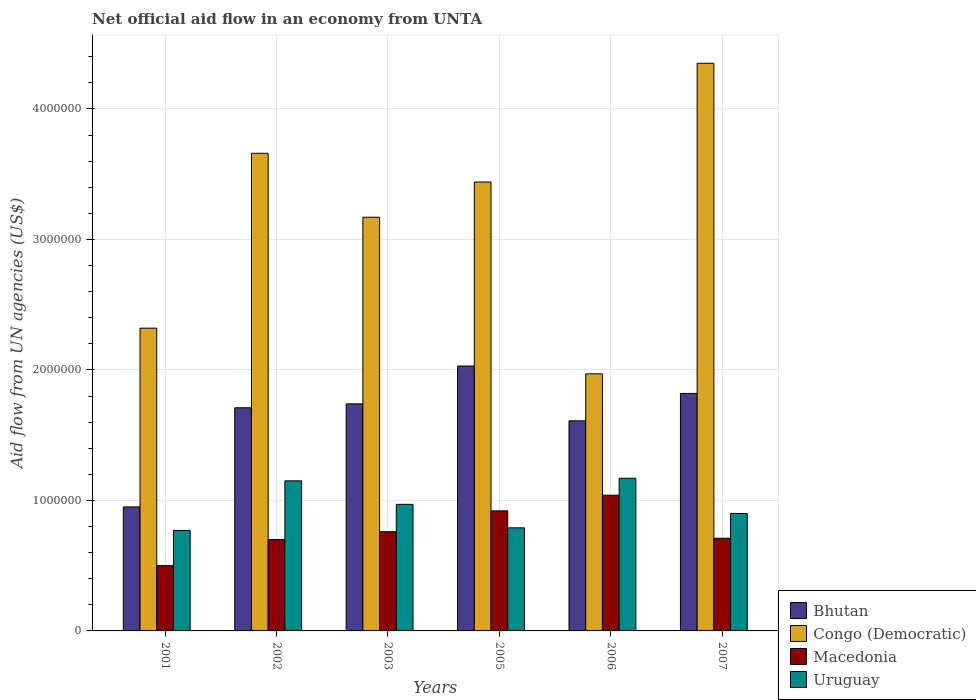How many groups of bars are there?
Provide a succinct answer. 6. Are the number of bars on each tick of the X-axis equal?
Ensure brevity in your answer.  Yes. How many bars are there on the 2nd tick from the left?
Ensure brevity in your answer.  4. How many bars are there on the 6th tick from the right?
Provide a short and direct response. 4. What is the label of the 4th group of bars from the left?
Keep it short and to the point. 2005. What is the net official aid flow in Macedonia in 2006?
Your answer should be compact. 1.04e+06. Across all years, what is the maximum net official aid flow in Congo (Democratic)?
Provide a short and direct response. 4.35e+06. In which year was the net official aid flow in Bhutan maximum?
Offer a very short reply. 2005. What is the total net official aid flow in Macedonia in the graph?
Offer a terse response. 4.63e+06. What is the difference between the net official aid flow in Bhutan in 2002 and that in 2006?
Keep it short and to the point. 1.00e+05. What is the difference between the net official aid flow in Macedonia in 2003 and the net official aid flow in Bhutan in 2006?
Keep it short and to the point. -8.50e+05. What is the average net official aid flow in Macedonia per year?
Your answer should be compact. 7.72e+05. In the year 2006, what is the difference between the net official aid flow in Bhutan and net official aid flow in Macedonia?
Keep it short and to the point. 5.70e+05. In how many years, is the net official aid flow in Uruguay greater than 2600000 US$?
Your answer should be compact. 0. Is the difference between the net official aid flow in Bhutan in 2001 and 2005 greater than the difference between the net official aid flow in Macedonia in 2001 and 2005?
Your response must be concise. No. Is the sum of the net official aid flow in Bhutan in 2002 and 2007 greater than the maximum net official aid flow in Congo (Democratic) across all years?
Your answer should be compact. No. What does the 3rd bar from the left in 2002 represents?
Your answer should be compact. Macedonia. What does the 2nd bar from the right in 2003 represents?
Your answer should be very brief. Macedonia. Are all the bars in the graph horizontal?
Keep it short and to the point. No. Are the values on the major ticks of Y-axis written in scientific E-notation?
Offer a terse response. No. What is the title of the graph?
Ensure brevity in your answer.  Net official aid flow in an economy from UNTA. Does "Equatorial Guinea" appear as one of the legend labels in the graph?
Ensure brevity in your answer.  No. What is the label or title of the Y-axis?
Offer a very short reply. Aid flow from UN agencies (US$). What is the Aid flow from UN agencies (US$) of Bhutan in 2001?
Offer a terse response. 9.50e+05. What is the Aid flow from UN agencies (US$) of Congo (Democratic) in 2001?
Provide a succinct answer. 2.32e+06. What is the Aid flow from UN agencies (US$) of Uruguay in 2001?
Give a very brief answer. 7.70e+05. What is the Aid flow from UN agencies (US$) of Bhutan in 2002?
Ensure brevity in your answer.  1.71e+06. What is the Aid flow from UN agencies (US$) of Congo (Democratic) in 2002?
Provide a short and direct response. 3.66e+06. What is the Aid flow from UN agencies (US$) in Uruguay in 2002?
Your answer should be very brief. 1.15e+06. What is the Aid flow from UN agencies (US$) of Bhutan in 2003?
Provide a succinct answer. 1.74e+06. What is the Aid flow from UN agencies (US$) in Congo (Democratic) in 2003?
Keep it short and to the point. 3.17e+06. What is the Aid flow from UN agencies (US$) of Macedonia in 2003?
Offer a terse response. 7.60e+05. What is the Aid flow from UN agencies (US$) of Uruguay in 2003?
Offer a terse response. 9.70e+05. What is the Aid flow from UN agencies (US$) in Bhutan in 2005?
Your response must be concise. 2.03e+06. What is the Aid flow from UN agencies (US$) in Congo (Democratic) in 2005?
Provide a short and direct response. 3.44e+06. What is the Aid flow from UN agencies (US$) of Macedonia in 2005?
Your response must be concise. 9.20e+05. What is the Aid flow from UN agencies (US$) of Uruguay in 2005?
Ensure brevity in your answer.  7.90e+05. What is the Aid flow from UN agencies (US$) of Bhutan in 2006?
Give a very brief answer. 1.61e+06. What is the Aid flow from UN agencies (US$) of Congo (Democratic) in 2006?
Offer a very short reply. 1.97e+06. What is the Aid flow from UN agencies (US$) of Macedonia in 2006?
Give a very brief answer. 1.04e+06. What is the Aid flow from UN agencies (US$) of Uruguay in 2006?
Offer a terse response. 1.17e+06. What is the Aid flow from UN agencies (US$) in Bhutan in 2007?
Provide a short and direct response. 1.82e+06. What is the Aid flow from UN agencies (US$) in Congo (Democratic) in 2007?
Provide a succinct answer. 4.35e+06. What is the Aid flow from UN agencies (US$) of Macedonia in 2007?
Your response must be concise. 7.10e+05. Across all years, what is the maximum Aid flow from UN agencies (US$) of Bhutan?
Give a very brief answer. 2.03e+06. Across all years, what is the maximum Aid flow from UN agencies (US$) of Congo (Democratic)?
Provide a succinct answer. 4.35e+06. Across all years, what is the maximum Aid flow from UN agencies (US$) of Macedonia?
Keep it short and to the point. 1.04e+06. Across all years, what is the maximum Aid flow from UN agencies (US$) in Uruguay?
Ensure brevity in your answer.  1.17e+06. Across all years, what is the minimum Aid flow from UN agencies (US$) of Bhutan?
Your response must be concise. 9.50e+05. Across all years, what is the minimum Aid flow from UN agencies (US$) of Congo (Democratic)?
Your answer should be very brief. 1.97e+06. Across all years, what is the minimum Aid flow from UN agencies (US$) in Macedonia?
Provide a succinct answer. 5.00e+05. Across all years, what is the minimum Aid flow from UN agencies (US$) of Uruguay?
Your response must be concise. 7.70e+05. What is the total Aid flow from UN agencies (US$) in Bhutan in the graph?
Offer a terse response. 9.86e+06. What is the total Aid flow from UN agencies (US$) of Congo (Democratic) in the graph?
Your answer should be very brief. 1.89e+07. What is the total Aid flow from UN agencies (US$) in Macedonia in the graph?
Provide a succinct answer. 4.63e+06. What is the total Aid flow from UN agencies (US$) of Uruguay in the graph?
Give a very brief answer. 5.75e+06. What is the difference between the Aid flow from UN agencies (US$) of Bhutan in 2001 and that in 2002?
Your answer should be very brief. -7.60e+05. What is the difference between the Aid flow from UN agencies (US$) in Congo (Democratic) in 2001 and that in 2002?
Make the answer very short. -1.34e+06. What is the difference between the Aid flow from UN agencies (US$) of Uruguay in 2001 and that in 2002?
Provide a succinct answer. -3.80e+05. What is the difference between the Aid flow from UN agencies (US$) of Bhutan in 2001 and that in 2003?
Give a very brief answer. -7.90e+05. What is the difference between the Aid flow from UN agencies (US$) of Congo (Democratic) in 2001 and that in 2003?
Give a very brief answer. -8.50e+05. What is the difference between the Aid flow from UN agencies (US$) of Uruguay in 2001 and that in 2003?
Make the answer very short. -2.00e+05. What is the difference between the Aid flow from UN agencies (US$) in Bhutan in 2001 and that in 2005?
Give a very brief answer. -1.08e+06. What is the difference between the Aid flow from UN agencies (US$) of Congo (Democratic) in 2001 and that in 2005?
Offer a very short reply. -1.12e+06. What is the difference between the Aid flow from UN agencies (US$) of Macedonia in 2001 and that in 2005?
Your answer should be very brief. -4.20e+05. What is the difference between the Aid flow from UN agencies (US$) in Uruguay in 2001 and that in 2005?
Your answer should be compact. -2.00e+04. What is the difference between the Aid flow from UN agencies (US$) in Bhutan in 2001 and that in 2006?
Provide a short and direct response. -6.60e+05. What is the difference between the Aid flow from UN agencies (US$) of Congo (Democratic) in 2001 and that in 2006?
Your response must be concise. 3.50e+05. What is the difference between the Aid flow from UN agencies (US$) of Macedonia in 2001 and that in 2006?
Make the answer very short. -5.40e+05. What is the difference between the Aid flow from UN agencies (US$) of Uruguay in 2001 and that in 2006?
Your response must be concise. -4.00e+05. What is the difference between the Aid flow from UN agencies (US$) of Bhutan in 2001 and that in 2007?
Offer a terse response. -8.70e+05. What is the difference between the Aid flow from UN agencies (US$) of Congo (Democratic) in 2001 and that in 2007?
Offer a terse response. -2.03e+06. What is the difference between the Aid flow from UN agencies (US$) in Congo (Democratic) in 2002 and that in 2003?
Your response must be concise. 4.90e+05. What is the difference between the Aid flow from UN agencies (US$) of Macedonia in 2002 and that in 2003?
Provide a short and direct response. -6.00e+04. What is the difference between the Aid flow from UN agencies (US$) of Uruguay in 2002 and that in 2003?
Your response must be concise. 1.80e+05. What is the difference between the Aid flow from UN agencies (US$) of Bhutan in 2002 and that in 2005?
Ensure brevity in your answer.  -3.20e+05. What is the difference between the Aid flow from UN agencies (US$) in Congo (Democratic) in 2002 and that in 2005?
Offer a terse response. 2.20e+05. What is the difference between the Aid flow from UN agencies (US$) of Uruguay in 2002 and that in 2005?
Ensure brevity in your answer.  3.60e+05. What is the difference between the Aid flow from UN agencies (US$) of Bhutan in 2002 and that in 2006?
Your answer should be very brief. 1.00e+05. What is the difference between the Aid flow from UN agencies (US$) in Congo (Democratic) in 2002 and that in 2006?
Offer a terse response. 1.69e+06. What is the difference between the Aid flow from UN agencies (US$) of Macedonia in 2002 and that in 2006?
Keep it short and to the point. -3.40e+05. What is the difference between the Aid flow from UN agencies (US$) of Uruguay in 2002 and that in 2006?
Offer a terse response. -2.00e+04. What is the difference between the Aid flow from UN agencies (US$) in Bhutan in 2002 and that in 2007?
Make the answer very short. -1.10e+05. What is the difference between the Aid flow from UN agencies (US$) of Congo (Democratic) in 2002 and that in 2007?
Provide a succinct answer. -6.90e+05. What is the difference between the Aid flow from UN agencies (US$) in Uruguay in 2002 and that in 2007?
Provide a succinct answer. 2.50e+05. What is the difference between the Aid flow from UN agencies (US$) in Bhutan in 2003 and that in 2005?
Offer a terse response. -2.90e+05. What is the difference between the Aid flow from UN agencies (US$) in Congo (Democratic) in 2003 and that in 2005?
Provide a succinct answer. -2.70e+05. What is the difference between the Aid flow from UN agencies (US$) in Macedonia in 2003 and that in 2005?
Your answer should be compact. -1.60e+05. What is the difference between the Aid flow from UN agencies (US$) of Uruguay in 2003 and that in 2005?
Keep it short and to the point. 1.80e+05. What is the difference between the Aid flow from UN agencies (US$) of Bhutan in 2003 and that in 2006?
Give a very brief answer. 1.30e+05. What is the difference between the Aid flow from UN agencies (US$) in Congo (Democratic) in 2003 and that in 2006?
Provide a short and direct response. 1.20e+06. What is the difference between the Aid flow from UN agencies (US$) of Macedonia in 2003 and that in 2006?
Your answer should be very brief. -2.80e+05. What is the difference between the Aid flow from UN agencies (US$) of Uruguay in 2003 and that in 2006?
Your answer should be very brief. -2.00e+05. What is the difference between the Aid flow from UN agencies (US$) of Congo (Democratic) in 2003 and that in 2007?
Provide a succinct answer. -1.18e+06. What is the difference between the Aid flow from UN agencies (US$) of Macedonia in 2003 and that in 2007?
Ensure brevity in your answer.  5.00e+04. What is the difference between the Aid flow from UN agencies (US$) of Bhutan in 2005 and that in 2006?
Your answer should be compact. 4.20e+05. What is the difference between the Aid flow from UN agencies (US$) of Congo (Democratic) in 2005 and that in 2006?
Offer a very short reply. 1.47e+06. What is the difference between the Aid flow from UN agencies (US$) in Macedonia in 2005 and that in 2006?
Ensure brevity in your answer.  -1.20e+05. What is the difference between the Aid flow from UN agencies (US$) of Uruguay in 2005 and that in 2006?
Offer a very short reply. -3.80e+05. What is the difference between the Aid flow from UN agencies (US$) in Bhutan in 2005 and that in 2007?
Ensure brevity in your answer.  2.10e+05. What is the difference between the Aid flow from UN agencies (US$) in Congo (Democratic) in 2005 and that in 2007?
Ensure brevity in your answer.  -9.10e+05. What is the difference between the Aid flow from UN agencies (US$) of Bhutan in 2006 and that in 2007?
Ensure brevity in your answer.  -2.10e+05. What is the difference between the Aid flow from UN agencies (US$) of Congo (Democratic) in 2006 and that in 2007?
Your response must be concise. -2.38e+06. What is the difference between the Aid flow from UN agencies (US$) in Macedonia in 2006 and that in 2007?
Offer a terse response. 3.30e+05. What is the difference between the Aid flow from UN agencies (US$) in Uruguay in 2006 and that in 2007?
Make the answer very short. 2.70e+05. What is the difference between the Aid flow from UN agencies (US$) in Bhutan in 2001 and the Aid flow from UN agencies (US$) in Congo (Democratic) in 2002?
Provide a succinct answer. -2.71e+06. What is the difference between the Aid flow from UN agencies (US$) in Bhutan in 2001 and the Aid flow from UN agencies (US$) in Uruguay in 2002?
Your answer should be very brief. -2.00e+05. What is the difference between the Aid flow from UN agencies (US$) of Congo (Democratic) in 2001 and the Aid flow from UN agencies (US$) of Macedonia in 2002?
Ensure brevity in your answer.  1.62e+06. What is the difference between the Aid flow from UN agencies (US$) of Congo (Democratic) in 2001 and the Aid flow from UN agencies (US$) of Uruguay in 2002?
Your answer should be compact. 1.17e+06. What is the difference between the Aid flow from UN agencies (US$) in Macedonia in 2001 and the Aid flow from UN agencies (US$) in Uruguay in 2002?
Ensure brevity in your answer.  -6.50e+05. What is the difference between the Aid flow from UN agencies (US$) in Bhutan in 2001 and the Aid flow from UN agencies (US$) in Congo (Democratic) in 2003?
Provide a succinct answer. -2.22e+06. What is the difference between the Aid flow from UN agencies (US$) of Bhutan in 2001 and the Aid flow from UN agencies (US$) of Uruguay in 2003?
Provide a short and direct response. -2.00e+04. What is the difference between the Aid flow from UN agencies (US$) of Congo (Democratic) in 2001 and the Aid flow from UN agencies (US$) of Macedonia in 2003?
Provide a succinct answer. 1.56e+06. What is the difference between the Aid flow from UN agencies (US$) of Congo (Democratic) in 2001 and the Aid flow from UN agencies (US$) of Uruguay in 2003?
Make the answer very short. 1.35e+06. What is the difference between the Aid flow from UN agencies (US$) of Macedonia in 2001 and the Aid flow from UN agencies (US$) of Uruguay in 2003?
Give a very brief answer. -4.70e+05. What is the difference between the Aid flow from UN agencies (US$) of Bhutan in 2001 and the Aid flow from UN agencies (US$) of Congo (Democratic) in 2005?
Your response must be concise. -2.49e+06. What is the difference between the Aid flow from UN agencies (US$) of Bhutan in 2001 and the Aid flow from UN agencies (US$) of Macedonia in 2005?
Give a very brief answer. 3.00e+04. What is the difference between the Aid flow from UN agencies (US$) of Bhutan in 2001 and the Aid flow from UN agencies (US$) of Uruguay in 2005?
Give a very brief answer. 1.60e+05. What is the difference between the Aid flow from UN agencies (US$) in Congo (Democratic) in 2001 and the Aid flow from UN agencies (US$) in Macedonia in 2005?
Your response must be concise. 1.40e+06. What is the difference between the Aid flow from UN agencies (US$) in Congo (Democratic) in 2001 and the Aid flow from UN agencies (US$) in Uruguay in 2005?
Ensure brevity in your answer.  1.53e+06. What is the difference between the Aid flow from UN agencies (US$) in Bhutan in 2001 and the Aid flow from UN agencies (US$) in Congo (Democratic) in 2006?
Your answer should be compact. -1.02e+06. What is the difference between the Aid flow from UN agencies (US$) of Congo (Democratic) in 2001 and the Aid flow from UN agencies (US$) of Macedonia in 2006?
Your answer should be very brief. 1.28e+06. What is the difference between the Aid flow from UN agencies (US$) of Congo (Democratic) in 2001 and the Aid flow from UN agencies (US$) of Uruguay in 2006?
Offer a terse response. 1.15e+06. What is the difference between the Aid flow from UN agencies (US$) in Macedonia in 2001 and the Aid flow from UN agencies (US$) in Uruguay in 2006?
Your answer should be very brief. -6.70e+05. What is the difference between the Aid flow from UN agencies (US$) in Bhutan in 2001 and the Aid flow from UN agencies (US$) in Congo (Democratic) in 2007?
Provide a short and direct response. -3.40e+06. What is the difference between the Aid flow from UN agencies (US$) in Bhutan in 2001 and the Aid flow from UN agencies (US$) in Uruguay in 2007?
Provide a succinct answer. 5.00e+04. What is the difference between the Aid flow from UN agencies (US$) in Congo (Democratic) in 2001 and the Aid flow from UN agencies (US$) in Macedonia in 2007?
Your response must be concise. 1.61e+06. What is the difference between the Aid flow from UN agencies (US$) in Congo (Democratic) in 2001 and the Aid flow from UN agencies (US$) in Uruguay in 2007?
Keep it short and to the point. 1.42e+06. What is the difference between the Aid flow from UN agencies (US$) in Macedonia in 2001 and the Aid flow from UN agencies (US$) in Uruguay in 2007?
Your response must be concise. -4.00e+05. What is the difference between the Aid flow from UN agencies (US$) of Bhutan in 2002 and the Aid flow from UN agencies (US$) of Congo (Democratic) in 2003?
Offer a very short reply. -1.46e+06. What is the difference between the Aid flow from UN agencies (US$) in Bhutan in 2002 and the Aid flow from UN agencies (US$) in Macedonia in 2003?
Your answer should be very brief. 9.50e+05. What is the difference between the Aid flow from UN agencies (US$) in Bhutan in 2002 and the Aid flow from UN agencies (US$) in Uruguay in 2003?
Your answer should be compact. 7.40e+05. What is the difference between the Aid flow from UN agencies (US$) of Congo (Democratic) in 2002 and the Aid flow from UN agencies (US$) of Macedonia in 2003?
Give a very brief answer. 2.90e+06. What is the difference between the Aid flow from UN agencies (US$) in Congo (Democratic) in 2002 and the Aid flow from UN agencies (US$) in Uruguay in 2003?
Your answer should be very brief. 2.69e+06. What is the difference between the Aid flow from UN agencies (US$) of Bhutan in 2002 and the Aid flow from UN agencies (US$) of Congo (Democratic) in 2005?
Make the answer very short. -1.73e+06. What is the difference between the Aid flow from UN agencies (US$) of Bhutan in 2002 and the Aid flow from UN agencies (US$) of Macedonia in 2005?
Keep it short and to the point. 7.90e+05. What is the difference between the Aid flow from UN agencies (US$) of Bhutan in 2002 and the Aid flow from UN agencies (US$) of Uruguay in 2005?
Your answer should be compact. 9.20e+05. What is the difference between the Aid flow from UN agencies (US$) in Congo (Democratic) in 2002 and the Aid flow from UN agencies (US$) in Macedonia in 2005?
Provide a succinct answer. 2.74e+06. What is the difference between the Aid flow from UN agencies (US$) in Congo (Democratic) in 2002 and the Aid flow from UN agencies (US$) in Uruguay in 2005?
Keep it short and to the point. 2.87e+06. What is the difference between the Aid flow from UN agencies (US$) in Macedonia in 2002 and the Aid flow from UN agencies (US$) in Uruguay in 2005?
Offer a very short reply. -9.00e+04. What is the difference between the Aid flow from UN agencies (US$) of Bhutan in 2002 and the Aid flow from UN agencies (US$) of Macedonia in 2006?
Your answer should be very brief. 6.70e+05. What is the difference between the Aid flow from UN agencies (US$) of Bhutan in 2002 and the Aid flow from UN agencies (US$) of Uruguay in 2006?
Your answer should be compact. 5.40e+05. What is the difference between the Aid flow from UN agencies (US$) in Congo (Democratic) in 2002 and the Aid flow from UN agencies (US$) in Macedonia in 2006?
Keep it short and to the point. 2.62e+06. What is the difference between the Aid flow from UN agencies (US$) in Congo (Democratic) in 2002 and the Aid flow from UN agencies (US$) in Uruguay in 2006?
Give a very brief answer. 2.49e+06. What is the difference between the Aid flow from UN agencies (US$) of Macedonia in 2002 and the Aid flow from UN agencies (US$) of Uruguay in 2006?
Your answer should be compact. -4.70e+05. What is the difference between the Aid flow from UN agencies (US$) of Bhutan in 2002 and the Aid flow from UN agencies (US$) of Congo (Democratic) in 2007?
Your answer should be very brief. -2.64e+06. What is the difference between the Aid flow from UN agencies (US$) in Bhutan in 2002 and the Aid flow from UN agencies (US$) in Uruguay in 2007?
Make the answer very short. 8.10e+05. What is the difference between the Aid flow from UN agencies (US$) in Congo (Democratic) in 2002 and the Aid flow from UN agencies (US$) in Macedonia in 2007?
Your answer should be very brief. 2.95e+06. What is the difference between the Aid flow from UN agencies (US$) of Congo (Democratic) in 2002 and the Aid flow from UN agencies (US$) of Uruguay in 2007?
Give a very brief answer. 2.76e+06. What is the difference between the Aid flow from UN agencies (US$) of Bhutan in 2003 and the Aid flow from UN agencies (US$) of Congo (Democratic) in 2005?
Offer a very short reply. -1.70e+06. What is the difference between the Aid flow from UN agencies (US$) in Bhutan in 2003 and the Aid flow from UN agencies (US$) in Macedonia in 2005?
Your answer should be very brief. 8.20e+05. What is the difference between the Aid flow from UN agencies (US$) in Bhutan in 2003 and the Aid flow from UN agencies (US$) in Uruguay in 2005?
Make the answer very short. 9.50e+05. What is the difference between the Aid flow from UN agencies (US$) of Congo (Democratic) in 2003 and the Aid flow from UN agencies (US$) of Macedonia in 2005?
Offer a terse response. 2.25e+06. What is the difference between the Aid flow from UN agencies (US$) of Congo (Democratic) in 2003 and the Aid flow from UN agencies (US$) of Uruguay in 2005?
Provide a short and direct response. 2.38e+06. What is the difference between the Aid flow from UN agencies (US$) of Macedonia in 2003 and the Aid flow from UN agencies (US$) of Uruguay in 2005?
Provide a short and direct response. -3.00e+04. What is the difference between the Aid flow from UN agencies (US$) in Bhutan in 2003 and the Aid flow from UN agencies (US$) in Uruguay in 2006?
Your response must be concise. 5.70e+05. What is the difference between the Aid flow from UN agencies (US$) of Congo (Democratic) in 2003 and the Aid flow from UN agencies (US$) of Macedonia in 2006?
Give a very brief answer. 2.13e+06. What is the difference between the Aid flow from UN agencies (US$) of Congo (Democratic) in 2003 and the Aid flow from UN agencies (US$) of Uruguay in 2006?
Ensure brevity in your answer.  2.00e+06. What is the difference between the Aid flow from UN agencies (US$) in Macedonia in 2003 and the Aid flow from UN agencies (US$) in Uruguay in 2006?
Your answer should be compact. -4.10e+05. What is the difference between the Aid flow from UN agencies (US$) of Bhutan in 2003 and the Aid flow from UN agencies (US$) of Congo (Democratic) in 2007?
Your response must be concise. -2.61e+06. What is the difference between the Aid flow from UN agencies (US$) in Bhutan in 2003 and the Aid flow from UN agencies (US$) in Macedonia in 2007?
Make the answer very short. 1.03e+06. What is the difference between the Aid flow from UN agencies (US$) of Bhutan in 2003 and the Aid flow from UN agencies (US$) of Uruguay in 2007?
Offer a very short reply. 8.40e+05. What is the difference between the Aid flow from UN agencies (US$) of Congo (Democratic) in 2003 and the Aid flow from UN agencies (US$) of Macedonia in 2007?
Your answer should be compact. 2.46e+06. What is the difference between the Aid flow from UN agencies (US$) of Congo (Democratic) in 2003 and the Aid flow from UN agencies (US$) of Uruguay in 2007?
Make the answer very short. 2.27e+06. What is the difference between the Aid flow from UN agencies (US$) of Macedonia in 2003 and the Aid flow from UN agencies (US$) of Uruguay in 2007?
Ensure brevity in your answer.  -1.40e+05. What is the difference between the Aid flow from UN agencies (US$) in Bhutan in 2005 and the Aid flow from UN agencies (US$) in Congo (Democratic) in 2006?
Ensure brevity in your answer.  6.00e+04. What is the difference between the Aid flow from UN agencies (US$) of Bhutan in 2005 and the Aid flow from UN agencies (US$) of Macedonia in 2006?
Give a very brief answer. 9.90e+05. What is the difference between the Aid flow from UN agencies (US$) in Bhutan in 2005 and the Aid flow from UN agencies (US$) in Uruguay in 2006?
Your answer should be compact. 8.60e+05. What is the difference between the Aid flow from UN agencies (US$) in Congo (Democratic) in 2005 and the Aid flow from UN agencies (US$) in Macedonia in 2006?
Give a very brief answer. 2.40e+06. What is the difference between the Aid flow from UN agencies (US$) in Congo (Democratic) in 2005 and the Aid flow from UN agencies (US$) in Uruguay in 2006?
Provide a succinct answer. 2.27e+06. What is the difference between the Aid flow from UN agencies (US$) of Macedonia in 2005 and the Aid flow from UN agencies (US$) of Uruguay in 2006?
Your answer should be very brief. -2.50e+05. What is the difference between the Aid flow from UN agencies (US$) in Bhutan in 2005 and the Aid flow from UN agencies (US$) in Congo (Democratic) in 2007?
Your answer should be compact. -2.32e+06. What is the difference between the Aid flow from UN agencies (US$) in Bhutan in 2005 and the Aid flow from UN agencies (US$) in Macedonia in 2007?
Provide a short and direct response. 1.32e+06. What is the difference between the Aid flow from UN agencies (US$) of Bhutan in 2005 and the Aid flow from UN agencies (US$) of Uruguay in 2007?
Offer a terse response. 1.13e+06. What is the difference between the Aid flow from UN agencies (US$) of Congo (Democratic) in 2005 and the Aid flow from UN agencies (US$) of Macedonia in 2007?
Make the answer very short. 2.73e+06. What is the difference between the Aid flow from UN agencies (US$) of Congo (Democratic) in 2005 and the Aid flow from UN agencies (US$) of Uruguay in 2007?
Your answer should be very brief. 2.54e+06. What is the difference between the Aid flow from UN agencies (US$) of Macedonia in 2005 and the Aid flow from UN agencies (US$) of Uruguay in 2007?
Make the answer very short. 2.00e+04. What is the difference between the Aid flow from UN agencies (US$) in Bhutan in 2006 and the Aid flow from UN agencies (US$) in Congo (Democratic) in 2007?
Your response must be concise. -2.74e+06. What is the difference between the Aid flow from UN agencies (US$) of Bhutan in 2006 and the Aid flow from UN agencies (US$) of Macedonia in 2007?
Your answer should be very brief. 9.00e+05. What is the difference between the Aid flow from UN agencies (US$) in Bhutan in 2006 and the Aid flow from UN agencies (US$) in Uruguay in 2007?
Keep it short and to the point. 7.10e+05. What is the difference between the Aid flow from UN agencies (US$) of Congo (Democratic) in 2006 and the Aid flow from UN agencies (US$) of Macedonia in 2007?
Keep it short and to the point. 1.26e+06. What is the difference between the Aid flow from UN agencies (US$) of Congo (Democratic) in 2006 and the Aid flow from UN agencies (US$) of Uruguay in 2007?
Make the answer very short. 1.07e+06. What is the difference between the Aid flow from UN agencies (US$) of Macedonia in 2006 and the Aid flow from UN agencies (US$) of Uruguay in 2007?
Provide a short and direct response. 1.40e+05. What is the average Aid flow from UN agencies (US$) in Bhutan per year?
Provide a succinct answer. 1.64e+06. What is the average Aid flow from UN agencies (US$) of Congo (Democratic) per year?
Your response must be concise. 3.15e+06. What is the average Aid flow from UN agencies (US$) of Macedonia per year?
Your answer should be compact. 7.72e+05. What is the average Aid flow from UN agencies (US$) of Uruguay per year?
Offer a very short reply. 9.58e+05. In the year 2001, what is the difference between the Aid flow from UN agencies (US$) of Bhutan and Aid flow from UN agencies (US$) of Congo (Democratic)?
Offer a terse response. -1.37e+06. In the year 2001, what is the difference between the Aid flow from UN agencies (US$) of Bhutan and Aid flow from UN agencies (US$) of Uruguay?
Offer a very short reply. 1.80e+05. In the year 2001, what is the difference between the Aid flow from UN agencies (US$) in Congo (Democratic) and Aid flow from UN agencies (US$) in Macedonia?
Provide a short and direct response. 1.82e+06. In the year 2001, what is the difference between the Aid flow from UN agencies (US$) of Congo (Democratic) and Aid flow from UN agencies (US$) of Uruguay?
Your response must be concise. 1.55e+06. In the year 2002, what is the difference between the Aid flow from UN agencies (US$) of Bhutan and Aid flow from UN agencies (US$) of Congo (Democratic)?
Provide a succinct answer. -1.95e+06. In the year 2002, what is the difference between the Aid flow from UN agencies (US$) of Bhutan and Aid flow from UN agencies (US$) of Macedonia?
Keep it short and to the point. 1.01e+06. In the year 2002, what is the difference between the Aid flow from UN agencies (US$) of Bhutan and Aid flow from UN agencies (US$) of Uruguay?
Your answer should be compact. 5.60e+05. In the year 2002, what is the difference between the Aid flow from UN agencies (US$) in Congo (Democratic) and Aid flow from UN agencies (US$) in Macedonia?
Provide a succinct answer. 2.96e+06. In the year 2002, what is the difference between the Aid flow from UN agencies (US$) of Congo (Democratic) and Aid flow from UN agencies (US$) of Uruguay?
Your answer should be very brief. 2.51e+06. In the year 2002, what is the difference between the Aid flow from UN agencies (US$) in Macedonia and Aid flow from UN agencies (US$) in Uruguay?
Ensure brevity in your answer.  -4.50e+05. In the year 2003, what is the difference between the Aid flow from UN agencies (US$) of Bhutan and Aid flow from UN agencies (US$) of Congo (Democratic)?
Keep it short and to the point. -1.43e+06. In the year 2003, what is the difference between the Aid flow from UN agencies (US$) of Bhutan and Aid flow from UN agencies (US$) of Macedonia?
Offer a very short reply. 9.80e+05. In the year 2003, what is the difference between the Aid flow from UN agencies (US$) of Bhutan and Aid flow from UN agencies (US$) of Uruguay?
Keep it short and to the point. 7.70e+05. In the year 2003, what is the difference between the Aid flow from UN agencies (US$) in Congo (Democratic) and Aid flow from UN agencies (US$) in Macedonia?
Ensure brevity in your answer.  2.41e+06. In the year 2003, what is the difference between the Aid flow from UN agencies (US$) of Congo (Democratic) and Aid flow from UN agencies (US$) of Uruguay?
Your response must be concise. 2.20e+06. In the year 2003, what is the difference between the Aid flow from UN agencies (US$) of Macedonia and Aid flow from UN agencies (US$) of Uruguay?
Ensure brevity in your answer.  -2.10e+05. In the year 2005, what is the difference between the Aid flow from UN agencies (US$) of Bhutan and Aid flow from UN agencies (US$) of Congo (Democratic)?
Provide a short and direct response. -1.41e+06. In the year 2005, what is the difference between the Aid flow from UN agencies (US$) in Bhutan and Aid flow from UN agencies (US$) in Macedonia?
Provide a succinct answer. 1.11e+06. In the year 2005, what is the difference between the Aid flow from UN agencies (US$) in Bhutan and Aid flow from UN agencies (US$) in Uruguay?
Make the answer very short. 1.24e+06. In the year 2005, what is the difference between the Aid flow from UN agencies (US$) in Congo (Democratic) and Aid flow from UN agencies (US$) in Macedonia?
Keep it short and to the point. 2.52e+06. In the year 2005, what is the difference between the Aid flow from UN agencies (US$) in Congo (Democratic) and Aid flow from UN agencies (US$) in Uruguay?
Provide a short and direct response. 2.65e+06. In the year 2006, what is the difference between the Aid flow from UN agencies (US$) in Bhutan and Aid flow from UN agencies (US$) in Congo (Democratic)?
Provide a short and direct response. -3.60e+05. In the year 2006, what is the difference between the Aid flow from UN agencies (US$) of Bhutan and Aid flow from UN agencies (US$) of Macedonia?
Ensure brevity in your answer.  5.70e+05. In the year 2006, what is the difference between the Aid flow from UN agencies (US$) in Congo (Democratic) and Aid flow from UN agencies (US$) in Macedonia?
Your response must be concise. 9.30e+05. In the year 2006, what is the difference between the Aid flow from UN agencies (US$) in Macedonia and Aid flow from UN agencies (US$) in Uruguay?
Give a very brief answer. -1.30e+05. In the year 2007, what is the difference between the Aid flow from UN agencies (US$) of Bhutan and Aid flow from UN agencies (US$) of Congo (Democratic)?
Your answer should be compact. -2.53e+06. In the year 2007, what is the difference between the Aid flow from UN agencies (US$) of Bhutan and Aid flow from UN agencies (US$) of Macedonia?
Your response must be concise. 1.11e+06. In the year 2007, what is the difference between the Aid flow from UN agencies (US$) of Bhutan and Aid flow from UN agencies (US$) of Uruguay?
Provide a succinct answer. 9.20e+05. In the year 2007, what is the difference between the Aid flow from UN agencies (US$) in Congo (Democratic) and Aid flow from UN agencies (US$) in Macedonia?
Give a very brief answer. 3.64e+06. In the year 2007, what is the difference between the Aid flow from UN agencies (US$) of Congo (Democratic) and Aid flow from UN agencies (US$) of Uruguay?
Your response must be concise. 3.45e+06. What is the ratio of the Aid flow from UN agencies (US$) in Bhutan in 2001 to that in 2002?
Your answer should be compact. 0.56. What is the ratio of the Aid flow from UN agencies (US$) in Congo (Democratic) in 2001 to that in 2002?
Make the answer very short. 0.63. What is the ratio of the Aid flow from UN agencies (US$) of Macedonia in 2001 to that in 2002?
Offer a very short reply. 0.71. What is the ratio of the Aid flow from UN agencies (US$) of Uruguay in 2001 to that in 2002?
Provide a succinct answer. 0.67. What is the ratio of the Aid flow from UN agencies (US$) in Bhutan in 2001 to that in 2003?
Offer a very short reply. 0.55. What is the ratio of the Aid flow from UN agencies (US$) of Congo (Democratic) in 2001 to that in 2003?
Give a very brief answer. 0.73. What is the ratio of the Aid flow from UN agencies (US$) of Macedonia in 2001 to that in 2003?
Ensure brevity in your answer.  0.66. What is the ratio of the Aid flow from UN agencies (US$) in Uruguay in 2001 to that in 2003?
Offer a very short reply. 0.79. What is the ratio of the Aid flow from UN agencies (US$) of Bhutan in 2001 to that in 2005?
Offer a terse response. 0.47. What is the ratio of the Aid flow from UN agencies (US$) in Congo (Democratic) in 2001 to that in 2005?
Keep it short and to the point. 0.67. What is the ratio of the Aid flow from UN agencies (US$) in Macedonia in 2001 to that in 2005?
Your answer should be very brief. 0.54. What is the ratio of the Aid flow from UN agencies (US$) in Uruguay in 2001 to that in 2005?
Your answer should be compact. 0.97. What is the ratio of the Aid flow from UN agencies (US$) in Bhutan in 2001 to that in 2006?
Ensure brevity in your answer.  0.59. What is the ratio of the Aid flow from UN agencies (US$) of Congo (Democratic) in 2001 to that in 2006?
Offer a very short reply. 1.18. What is the ratio of the Aid flow from UN agencies (US$) in Macedonia in 2001 to that in 2006?
Offer a very short reply. 0.48. What is the ratio of the Aid flow from UN agencies (US$) of Uruguay in 2001 to that in 2006?
Provide a short and direct response. 0.66. What is the ratio of the Aid flow from UN agencies (US$) of Bhutan in 2001 to that in 2007?
Your answer should be very brief. 0.52. What is the ratio of the Aid flow from UN agencies (US$) of Congo (Democratic) in 2001 to that in 2007?
Keep it short and to the point. 0.53. What is the ratio of the Aid flow from UN agencies (US$) of Macedonia in 2001 to that in 2007?
Give a very brief answer. 0.7. What is the ratio of the Aid flow from UN agencies (US$) in Uruguay in 2001 to that in 2007?
Offer a terse response. 0.86. What is the ratio of the Aid flow from UN agencies (US$) in Bhutan in 2002 to that in 2003?
Give a very brief answer. 0.98. What is the ratio of the Aid flow from UN agencies (US$) in Congo (Democratic) in 2002 to that in 2003?
Keep it short and to the point. 1.15. What is the ratio of the Aid flow from UN agencies (US$) in Macedonia in 2002 to that in 2003?
Offer a very short reply. 0.92. What is the ratio of the Aid flow from UN agencies (US$) in Uruguay in 2002 to that in 2003?
Offer a terse response. 1.19. What is the ratio of the Aid flow from UN agencies (US$) of Bhutan in 2002 to that in 2005?
Offer a terse response. 0.84. What is the ratio of the Aid flow from UN agencies (US$) of Congo (Democratic) in 2002 to that in 2005?
Offer a very short reply. 1.06. What is the ratio of the Aid flow from UN agencies (US$) in Macedonia in 2002 to that in 2005?
Ensure brevity in your answer.  0.76. What is the ratio of the Aid flow from UN agencies (US$) in Uruguay in 2002 to that in 2005?
Your response must be concise. 1.46. What is the ratio of the Aid flow from UN agencies (US$) in Bhutan in 2002 to that in 2006?
Provide a short and direct response. 1.06. What is the ratio of the Aid flow from UN agencies (US$) in Congo (Democratic) in 2002 to that in 2006?
Ensure brevity in your answer.  1.86. What is the ratio of the Aid flow from UN agencies (US$) in Macedonia in 2002 to that in 2006?
Ensure brevity in your answer.  0.67. What is the ratio of the Aid flow from UN agencies (US$) in Uruguay in 2002 to that in 2006?
Keep it short and to the point. 0.98. What is the ratio of the Aid flow from UN agencies (US$) in Bhutan in 2002 to that in 2007?
Offer a terse response. 0.94. What is the ratio of the Aid flow from UN agencies (US$) in Congo (Democratic) in 2002 to that in 2007?
Your answer should be very brief. 0.84. What is the ratio of the Aid flow from UN agencies (US$) in Macedonia in 2002 to that in 2007?
Offer a terse response. 0.99. What is the ratio of the Aid flow from UN agencies (US$) in Uruguay in 2002 to that in 2007?
Offer a very short reply. 1.28. What is the ratio of the Aid flow from UN agencies (US$) of Congo (Democratic) in 2003 to that in 2005?
Give a very brief answer. 0.92. What is the ratio of the Aid flow from UN agencies (US$) of Macedonia in 2003 to that in 2005?
Make the answer very short. 0.83. What is the ratio of the Aid flow from UN agencies (US$) of Uruguay in 2003 to that in 2005?
Offer a very short reply. 1.23. What is the ratio of the Aid flow from UN agencies (US$) of Bhutan in 2003 to that in 2006?
Offer a terse response. 1.08. What is the ratio of the Aid flow from UN agencies (US$) of Congo (Democratic) in 2003 to that in 2006?
Provide a short and direct response. 1.61. What is the ratio of the Aid flow from UN agencies (US$) of Macedonia in 2003 to that in 2006?
Offer a terse response. 0.73. What is the ratio of the Aid flow from UN agencies (US$) of Uruguay in 2003 to that in 2006?
Ensure brevity in your answer.  0.83. What is the ratio of the Aid flow from UN agencies (US$) in Bhutan in 2003 to that in 2007?
Provide a succinct answer. 0.96. What is the ratio of the Aid flow from UN agencies (US$) in Congo (Democratic) in 2003 to that in 2007?
Provide a short and direct response. 0.73. What is the ratio of the Aid flow from UN agencies (US$) of Macedonia in 2003 to that in 2007?
Keep it short and to the point. 1.07. What is the ratio of the Aid flow from UN agencies (US$) of Uruguay in 2003 to that in 2007?
Offer a terse response. 1.08. What is the ratio of the Aid flow from UN agencies (US$) of Bhutan in 2005 to that in 2006?
Your answer should be compact. 1.26. What is the ratio of the Aid flow from UN agencies (US$) in Congo (Democratic) in 2005 to that in 2006?
Your response must be concise. 1.75. What is the ratio of the Aid flow from UN agencies (US$) in Macedonia in 2005 to that in 2006?
Ensure brevity in your answer.  0.88. What is the ratio of the Aid flow from UN agencies (US$) of Uruguay in 2005 to that in 2006?
Offer a terse response. 0.68. What is the ratio of the Aid flow from UN agencies (US$) in Bhutan in 2005 to that in 2007?
Provide a succinct answer. 1.12. What is the ratio of the Aid flow from UN agencies (US$) of Congo (Democratic) in 2005 to that in 2007?
Your answer should be very brief. 0.79. What is the ratio of the Aid flow from UN agencies (US$) of Macedonia in 2005 to that in 2007?
Provide a short and direct response. 1.3. What is the ratio of the Aid flow from UN agencies (US$) of Uruguay in 2005 to that in 2007?
Your response must be concise. 0.88. What is the ratio of the Aid flow from UN agencies (US$) in Bhutan in 2006 to that in 2007?
Ensure brevity in your answer.  0.88. What is the ratio of the Aid flow from UN agencies (US$) in Congo (Democratic) in 2006 to that in 2007?
Keep it short and to the point. 0.45. What is the ratio of the Aid flow from UN agencies (US$) of Macedonia in 2006 to that in 2007?
Offer a terse response. 1.46. What is the difference between the highest and the second highest Aid flow from UN agencies (US$) in Congo (Democratic)?
Keep it short and to the point. 6.90e+05. What is the difference between the highest and the second highest Aid flow from UN agencies (US$) in Macedonia?
Give a very brief answer. 1.20e+05. What is the difference between the highest and the lowest Aid flow from UN agencies (US$) in Bhutan?
Your answer should be very brief. 1.08e+06. What is the difference between the highest and the lowest Aid flow from UN agencies (US$) in Congo (Democratic)?
Your answer should be compact. 2.38e+06. What is the difference between the highest and the lowest Aid flow from UN agencies (US$) of Macedonia?
Provide a succinct answer. 5.40e+05. What is the difference between the highest and the lowest Aid flow from UN agencies (US$) of Uruguay?
Your response must be concise. 4.00e+05. 